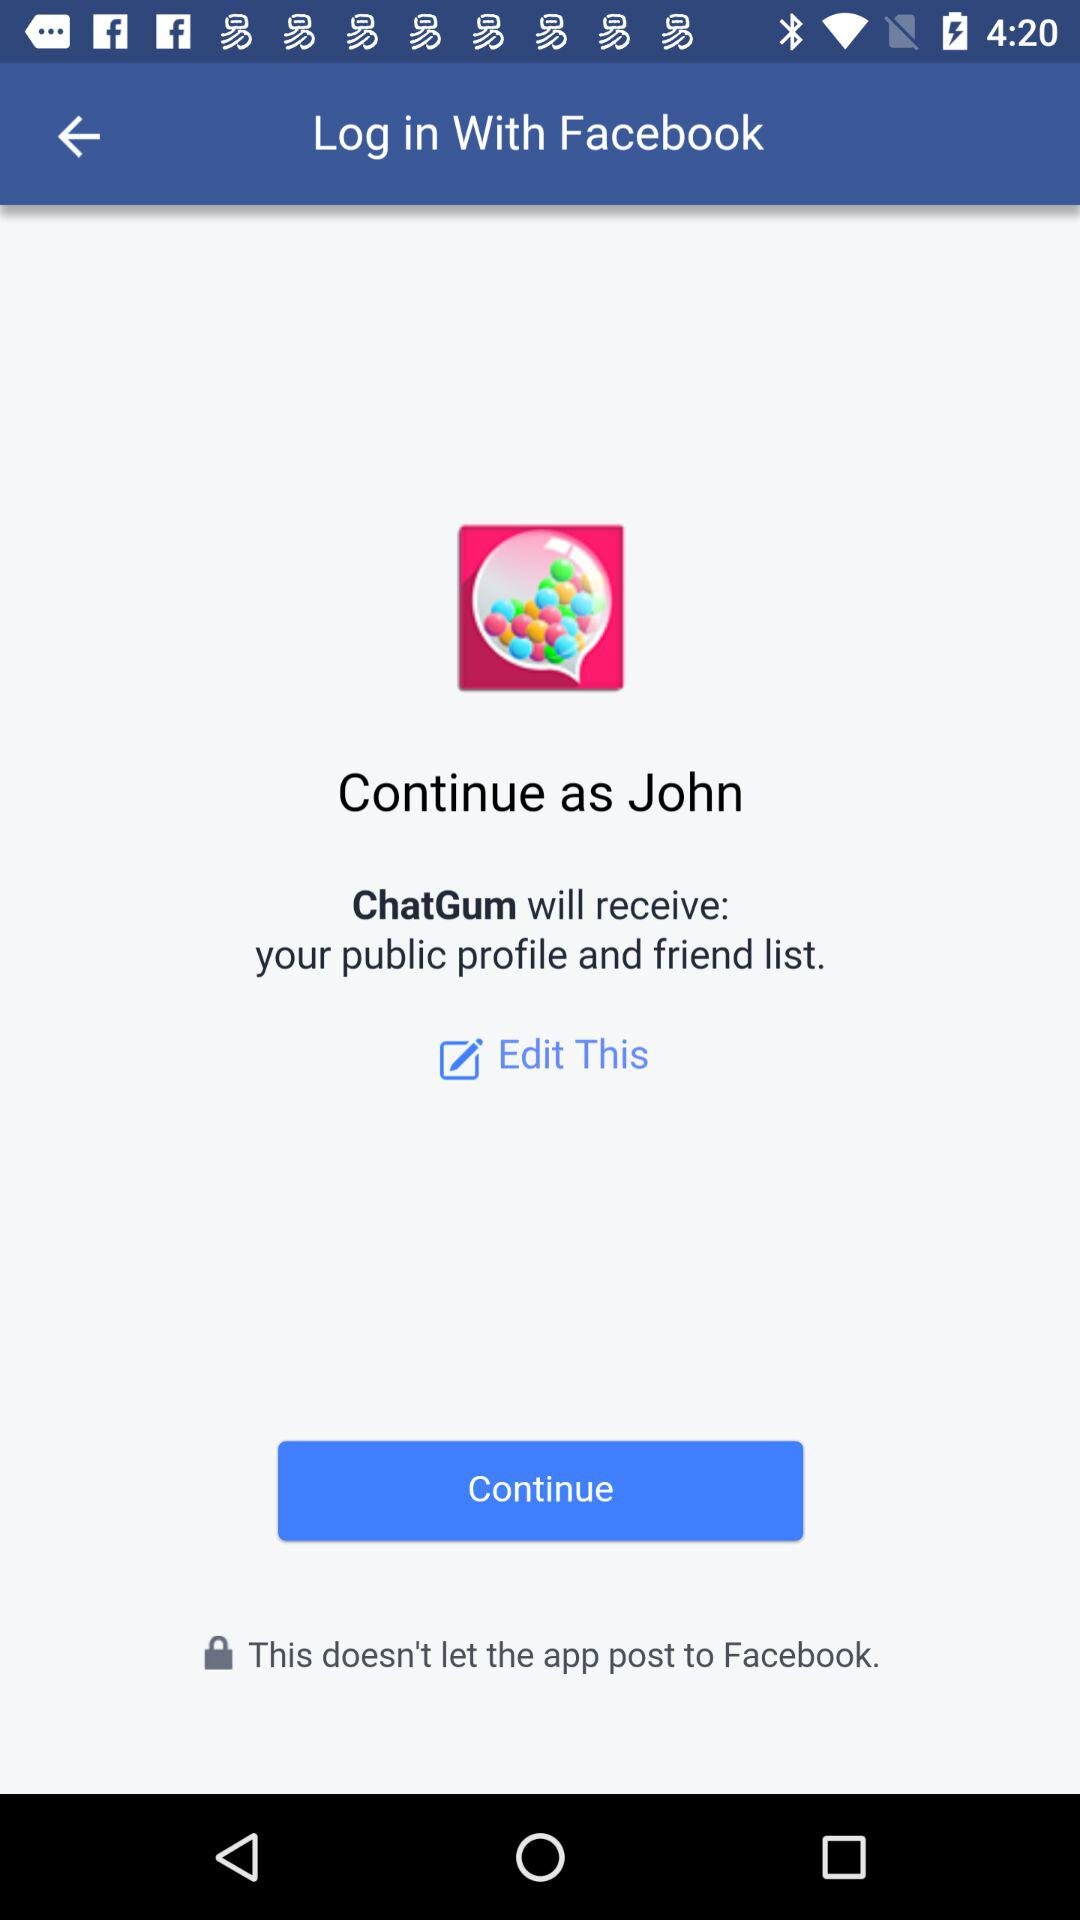What is the name of the user? The name of the user is John. 